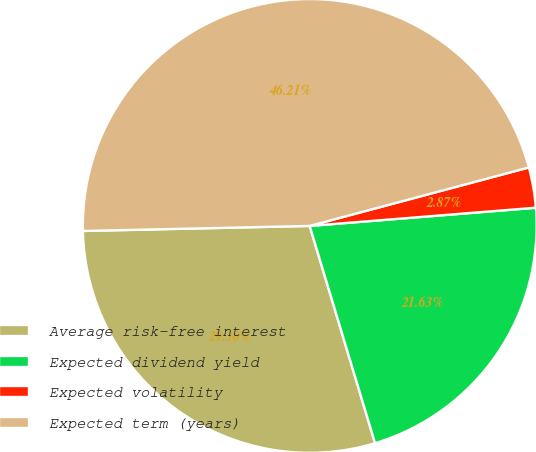<chart> <loc_0><loc_0><loc_500><loc_500><pie_chart><fcel>Average risk-free interest<fcel>Expected dividend yield<fcel>Expected volatility<fcel>Expected term (years)<nl><fcel>29.3%<fcel>21.63%<fcel>2.87%<fcel>46.21%<nl></chart> 